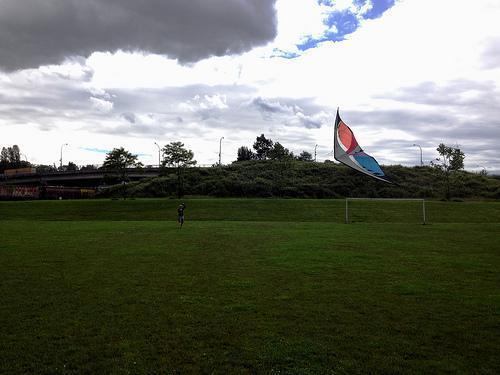How many people are shown?
Give a very brief answer. 1. 